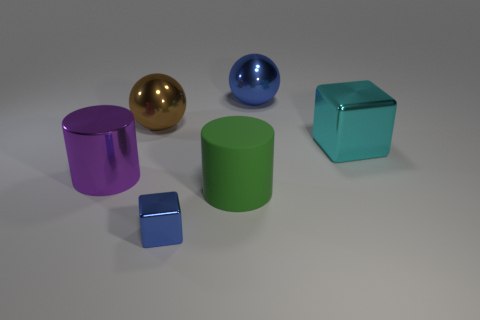Add 3 objects. How many objects exist? 9 Subtract all cylinders. How many objects are left? 4 Subtract all big blue balls. Subtract all balls. How many objects are left? 3 Add 1 big blue metallic objects. How many big blue metallic objects are left? 2 Add 2 large rubber objects. How many large rubber objects exist? 3 Subtract 0 green cubes. How many objects are left? 6 